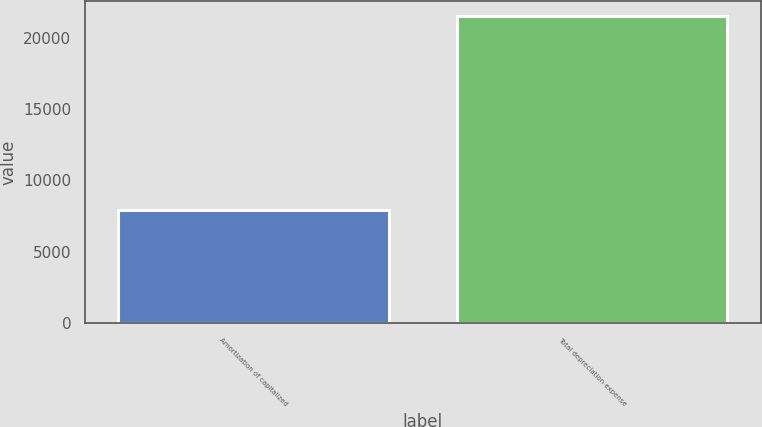Convert chart to OTSL. <chart><loc_0><loc_0><loc_500><loc_500><bar_chart><fcel>Amortization of capitalized<fcel>Total depreciation expense<nl><fcel>7912<fcel>21504<nl></chart> 